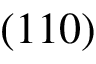<formula> <loc_0><loc_0><loc_500><loc_500>( 1 1 0 )</formula> 